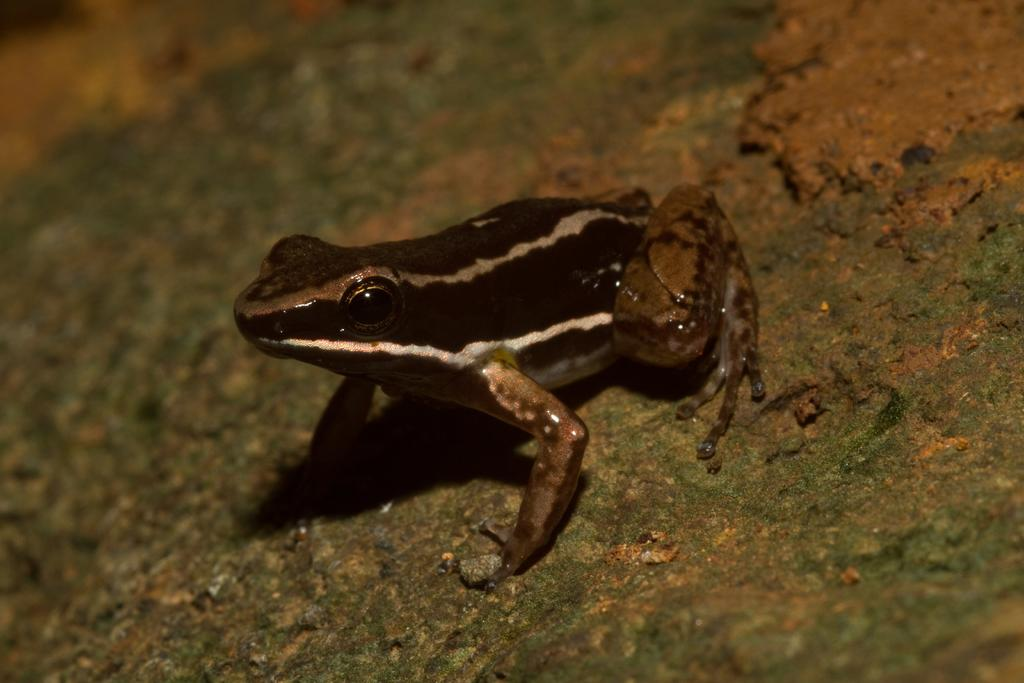What animal is present on the surface in the image? There is a frog on the surface in the image. What color is the background of the image? The background of the image is green. What type of cabbage is being played in the image? There is no cabbage or indication of any play activity in the image; it features a frog on a surface with a green background. 